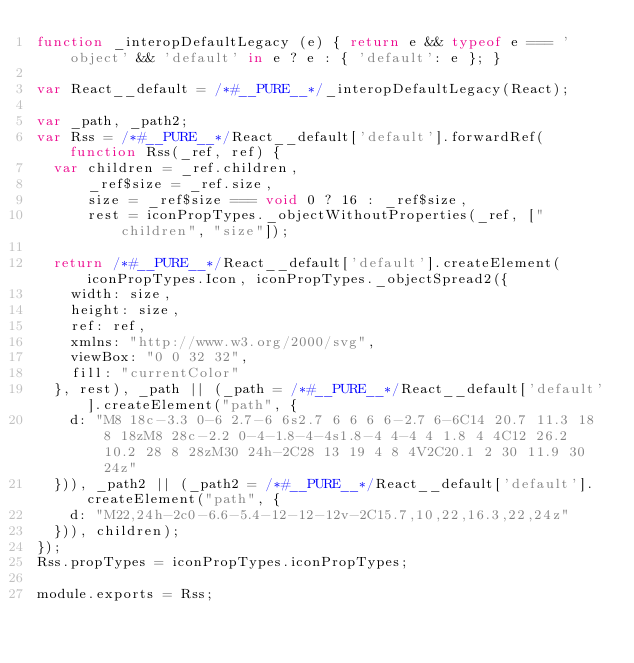Convert code to text. <code><loc_0><loc_0><loc_500><loc_500><_JavaScript_>function _interopDefaultLegacy (e) { return e && typeof e === 'object' && 'default' in e ? e : { 'default': e }; }

var React__default = /*#__PURE__*/_interopDefaultLegacy(React);

var _path, _path2;
var Rss = /*#__PURE__*/React__default['default'].forwardRef(function Rss(_ref, ref) {
  var children = _ref.children,
      _ref$size = _ref.size,
      size = _ref$size === void 0 ? 16 : _ref$size,
      rest = iconPropTypes._objectWithoutProperties(_ref, ["children", "size"]);

  return /*#__PURE__*/React__default['default'].createElement(iconPropTypes.Icon, iconPropTypes._objectSpread2({
    width: size,
    height: size,
    ref: ref,
    xmlns: "http://www.w3.org/2000/svg",
    viewBox: "0 0 32 32",
    fill: "currentColor"
  }, rest), _path || (_path = /*#__PURE__*/React__default['default'].createElement("path", {
    d: "M8 18c-3.3 0-6 2.7-6 6s2.7 6 6 6 6-2.7 6-6C14 20.7 11.3 18 8 18zM8 28c-2.2 0-4-1.8-4-4s1.8-4 4-4 4 1.8 4 4C12 26.2 10.2 28 8 28zM30 24h-2C28 13 19 4 8 4V2C20.1 2 30 11.9 30 24z"
  })), _path2 || (_path2 = /*#__PURE__*/React__default['default'].createElement("path", {
    d: "M22,24h-2c0-6.6-5.4-12-12-12v-2C15.7,10,22,16.3,22,24z"
  })), children);
});
Rss.propTypes = iconPropTypes.iconPropTypes;

module.exports = Rss;
</code> 